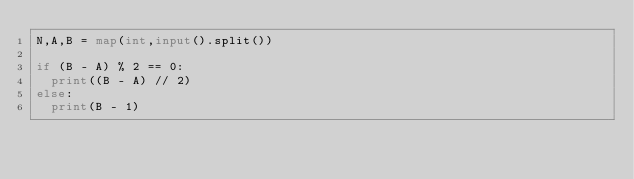<code> <loc_0><loc_0><loc_500><loc_500><_Python_>N,A,B = map(int,input().split())

if (B - A) % 2 == 0:
  print((B - A) // 2)
else:
  print(B - 1)</code> 